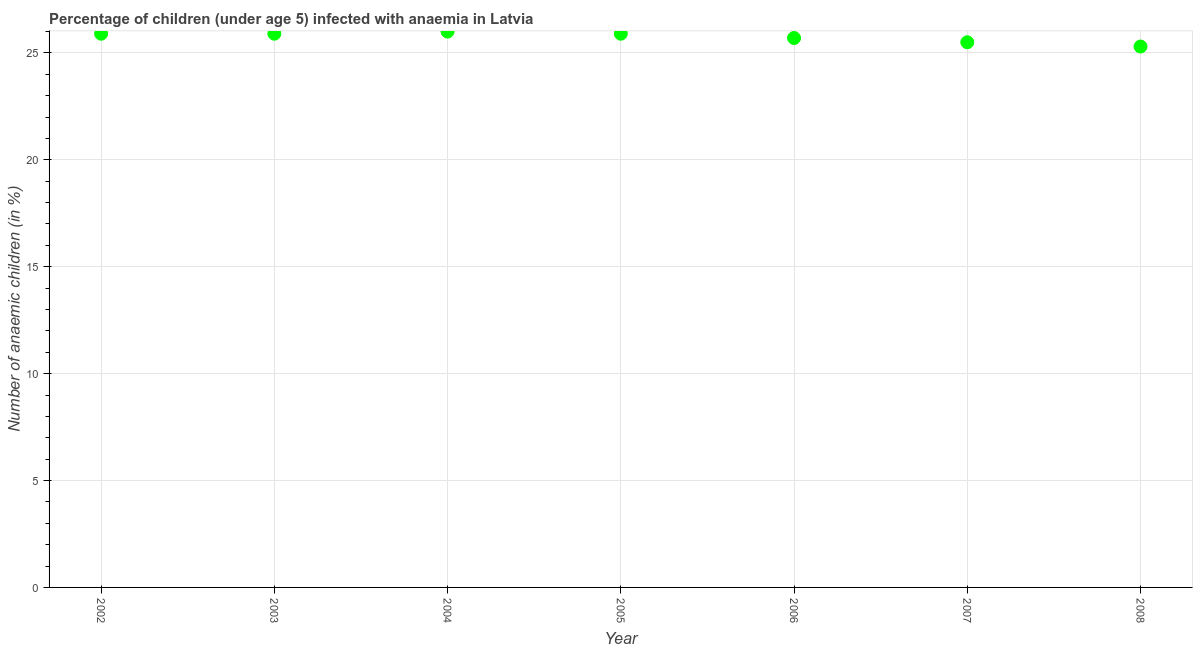Across all years, what is the minimum number of anaemic children?
Your answer should be compact. 25.3. In which year was the number of anaemic children minimum?
Your response must be concise. 2008. What is the sum of the number of anaemic children?
Provide a short and direct response. 180.2. What is the difference between the number of anaemic children in 2005 and 2008?
Offer a terse response. 0.6. What is the average number of anaemic children per year?
Give a very brief answer. 25.74. What is the median number of anaemic children?
Provide a succinct answer. 25.9. Do a majority of the years between 2002 and 2008 (inclusive) have number of anaemic children greater than 21 %?
Provide a short and direct response. Yes. What is the ratio of the number of anaemic children in 2004 to that in 2008?
Ensure brevity in your answer.  1.03. Is the number of anaemic children in 2004 less than that in 2008?
Offer a very short reply. No. Is the difference between the number of anaemic children in 2006 and 2007 greater than the difference between any two years?
Offer a terse response. No. What is the difference between the highest and the second highest number of anaemic children?
Make the answer very short. 0.1. Is the sum of the number of anaemic children in 2003 and 2006 greater than the maximum number of anaemic children across all years?
Give a very brief answer. Yes. What is the difference between the highest and the lowest number of anaemic children?
Give a very brief answer. 0.7. How many years are there in the graph?
Keep it short and to the point. 7. What is the title of the graph?
Keep it short and to the point. Percentage of children (under age 5) infected with anaemia in Latvia. What is the label or title of the Y-axis?
Keep it short and to the point. Number of anaemic children (in %). What is the Number of anaemic children (in %) in 2002?
Provide a succinct answer. 25.9. What is the Number of anaemic children (in %) in 2003?
Keep it short and to the point. 25.9. What is the Number of anaemic children (in %) in 2004?
Offer a terse response. 26. What is the Number of anaemic children (in %) in 2005?
Make the answer very short. 25.9. What is the Number of anaemic children (in %) in 2006?
Your response must be concise. 25.7. What is the Number of anaemic children (in %) in 2007?
Make the answer very short. 25.5. What is the Number of anaemic children (in %) in 2008?
Give a very brief answer. 25.3. What is the difference between the Number of anaemic children (in %) in 2002 and 2003?
Make the answer very short. 0. What is the difference between the Number of anaemic children (in %) in 2002 and 2004?
Provide a succinct answer. -0.1. What is the difference between the Number of anaemic children (in %) in 2002 and 2007?
Keep it short and to the point. 0.4. What is the difference between the Number of anaemic children (in %) in 2003 and 2004?
Your answer should be very brief. -0.1. What is the difference between the Number of anaemic children (in %) in 2003 and 2006?
Your answer should be compact. 0.2. What is the difference between the Number of anaemic children (in %) in 2003 and 2008?
Offer a terse response. 0.6. What is the difference between the Number of anaemic children (in %) in 2004 and 2008?
Make the answer very short. 0.7. What is the difference between the Number of anaemic children (in %) in 2005 and 2006?
Provide a short and direct response. 0.2. What is the difference between the Number of anaemic children (in %) in 2005 and 2007?
Your response must be concise. 0.4. What is the difference between the Number of anaemic children (in %) in 2006 and 2007?
Keep it short and to the point. 0.2. What is the difference between the Number of anaemic children (in %) in 2007 and 2008?
Offer a very short reply. 0.2. What is the ratio of the Number of anaemic children (in %) in 2002 to that in 2003?
Offer a terse response. 1. What is the ratio of the Number of anaemic children (in %) in 2002 to that in 2004?
Offer a very short reply. 1. What is the ratio of the Number of anaemic children (in %) in 2002 to that in 2006?
Ensure brevity in your answer.  1.01. What is the ratio of the Number of anaemic children (in %) in 2002 to that in 2007?
Offer a terse response. 1.02. What is the ratio of the Number of anaemic children (in %) in 2003 to that in 2006?
Give a very brief answer. 1.01. What is the ratio of the Number of anaemic children (in %) in 2003 to that in 2007?
Give a very brief answer. 1.02. What is the ratio of the Number of anaemic children (in %) in 2003 to that in 2008?
Provide a short and direct response. 1.02. What is the ratio of the Number of anaemic children (in %) in 2004 to that in 2005?
Ensure brevity in your answer.  1. What is the ratio of the Number of anaemic children (in %) in 2004 to that in 2006?
Make the answer very short. 1.01. What is the ratio of the Number of anaemic children (in %) in 2004 to that in 2007?
Offer a terse response. 1.02. What is the ratio of the Number of anaemic children (in %) in 2004 to that in 2008?
Your answer should be very brief. 1.03. What is the ratio of the Number of anaemic children (in %) in 2005 to that in 2006?
Make the answer very short. 1.01. What is the ratio of the Number of anaemic children (in %) in 2005 to that in 2008?
Your answer should be compact. 1.02. What is the ratio of the Number of anaemic children (in %) in 2006 to that in 2007?
Your answer should be very brief. 1.01. What is the ratio of the Number of anaemic children (in %) in 2006 to that in 2008?
Ensure brevity in your answer.  1.02. 